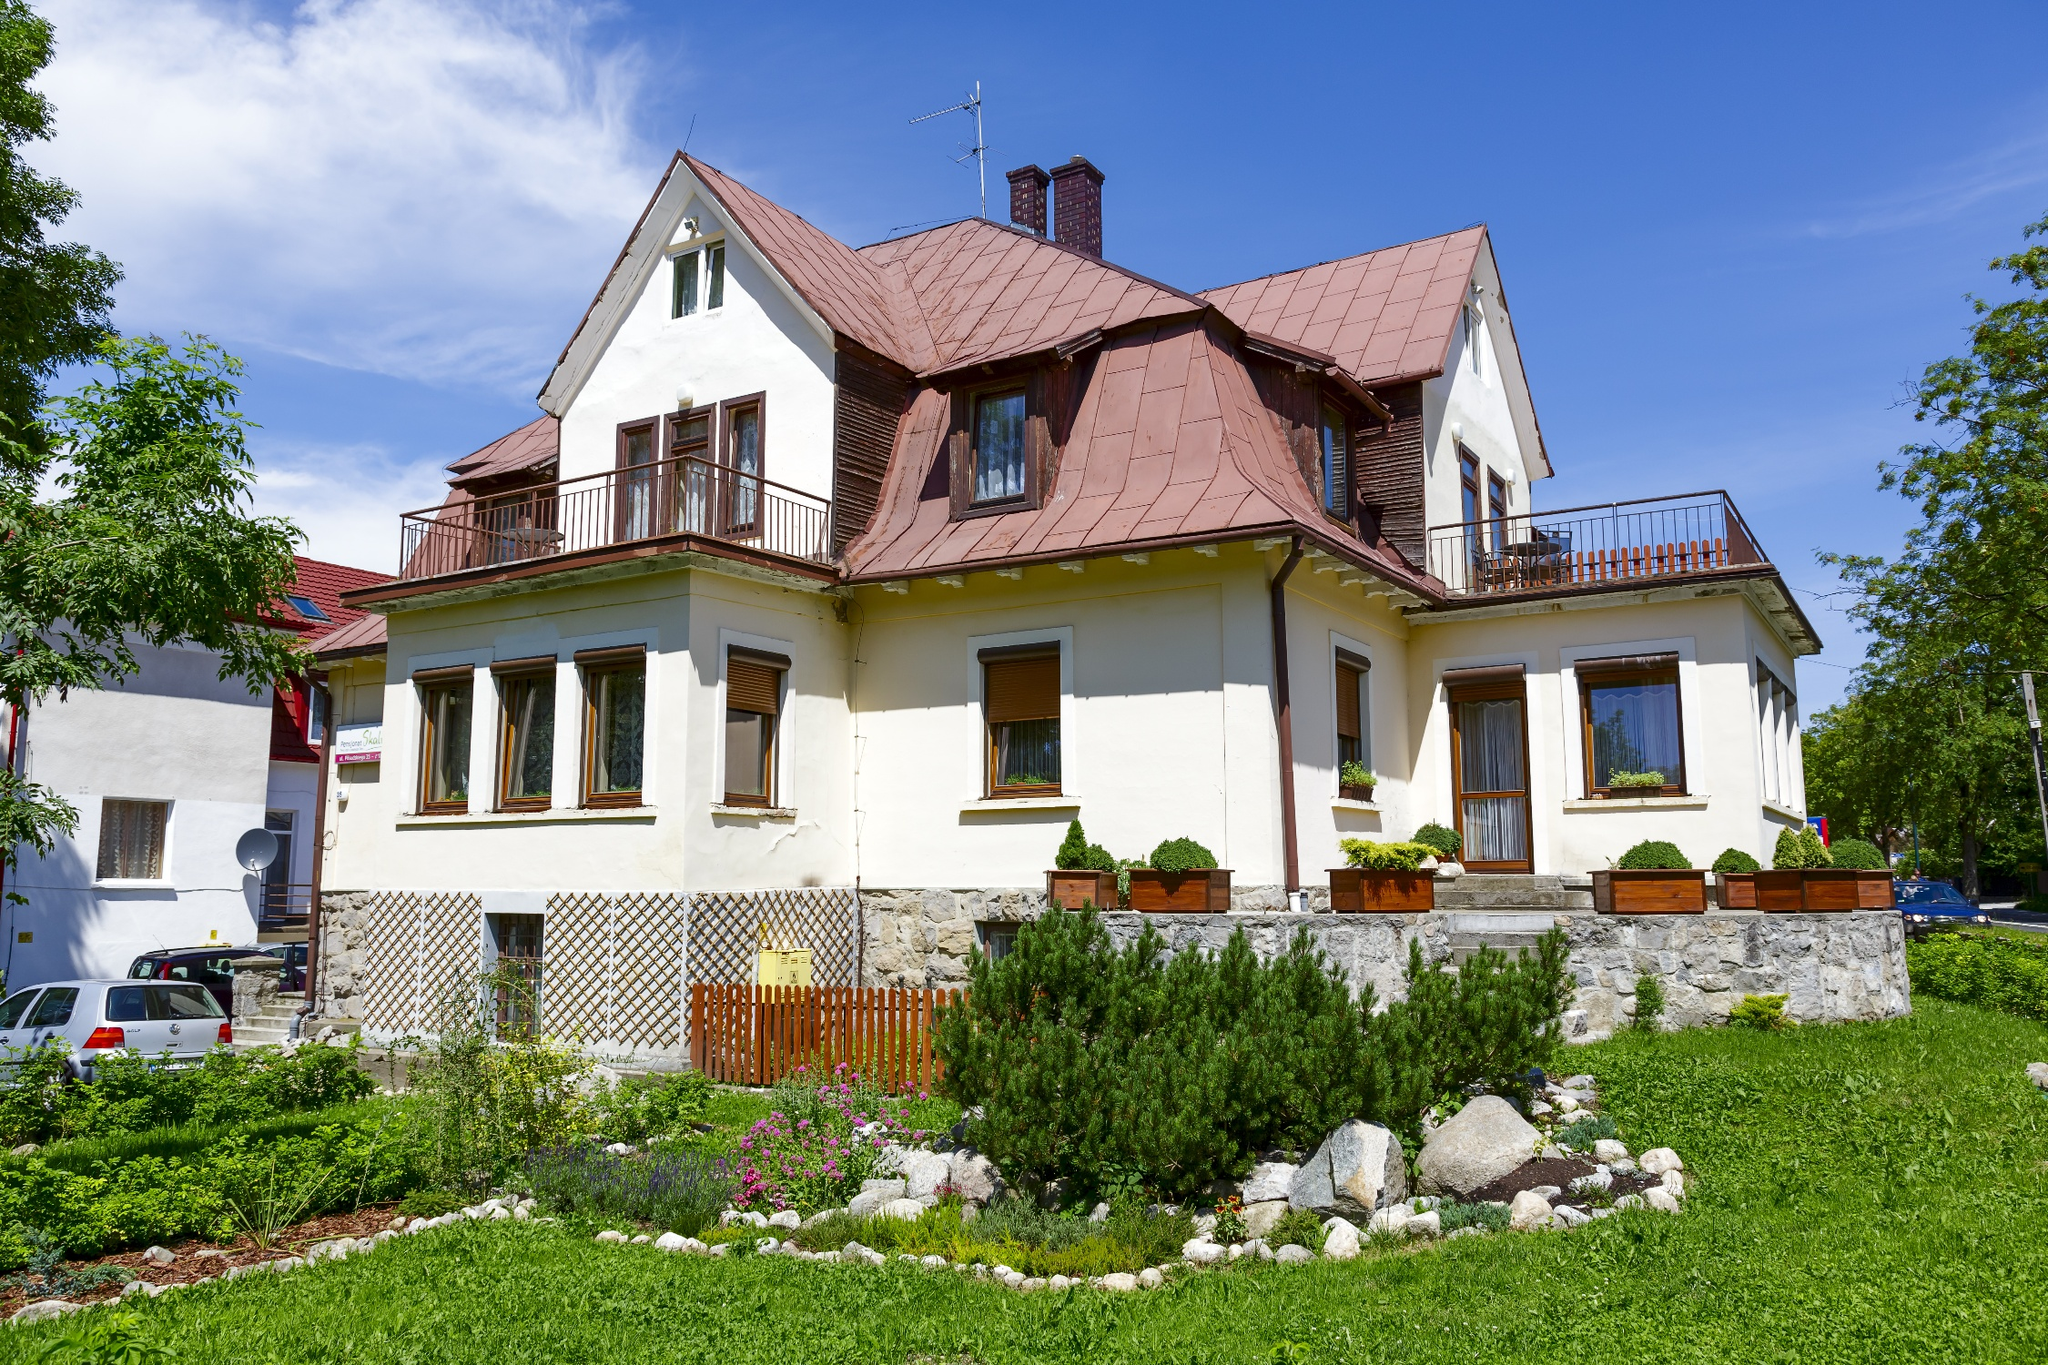What could be the potential uses of the garden area seen around the house? The garden area surrounding the house is richly planted and well-maintained, making it ideal for several uses. It could serve as a personal oasis for relaxation and mental rejuvenation, where someone could enjoy gardening or simply unwind amidst nature. Alternatively, it's perfect for hosting gatherings or outdoor activities, providing a picturesque setting for social events. Additionally, the diversity of plants could interest gardening enthusiasts looking to cultivate a variety of flora. Educational activities, such as teaching children about different plants and sustainable gardening practices, could also take place in this vibrant space. 